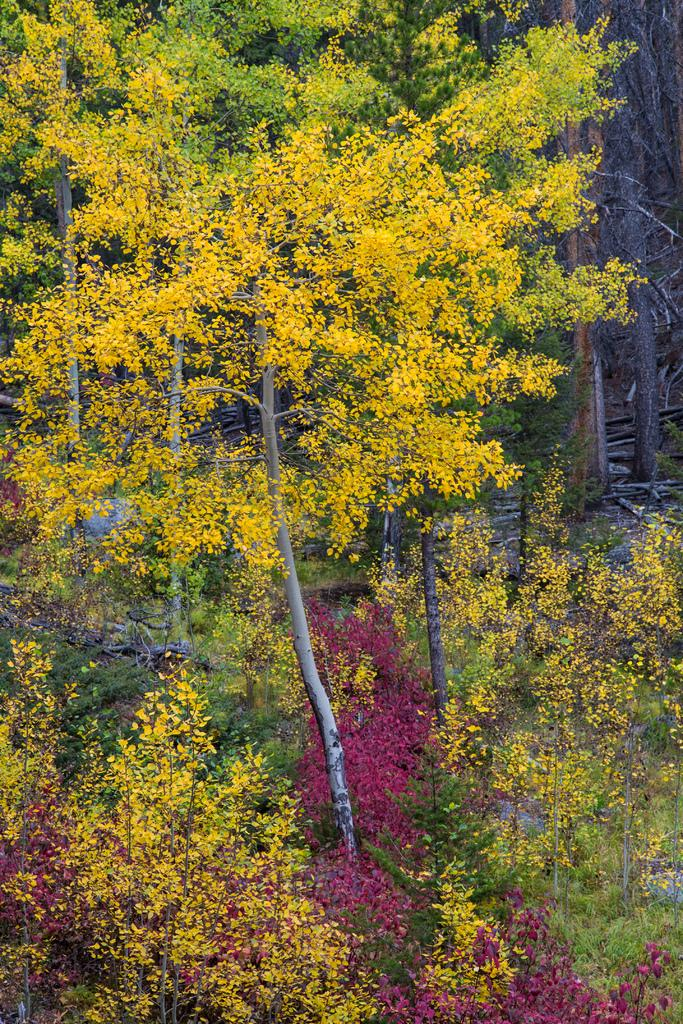What type of vegetation can be seen in the image? There are trees and plants in the image. What parts of the trees are visible in the image? Branches are visible in the image. What type of wing can be seen on the plants in the image? There are no wings present on the plants in the image. How is the string used in the image? There is no string present in the image. 